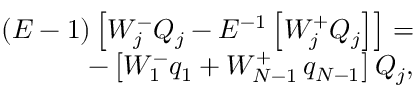Convert formula to latex. <formula><loc_0><loc_0><loc_500><loc_500>\begin{array} { r } { \left ( E - 1 \right ) \left [ W _ { j } ^ { - } Q _ { j } - E ^ { - 1 } \left [ W _ { j } ^ { + } Q _ { j } \right ] \right ] = } \\ { - \left [ W _ { 1 } ^ { - } q _ { 1 } + W _ { N - 1 } ^ { + } q _ { N - 1 } \right ] Q _ { j } , } \end{array}</formula> 